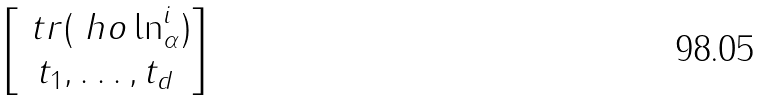Convert formula to latex. <formula><loc_0><loc_0><loc_500><loc_500>\begin{bmatrix} \ t r ( \ h o \ln ^ { i } _ { \alpha } ) \\ t _ { 1 } , \dots , t _ { d } \end{bmatrix}</formula> 